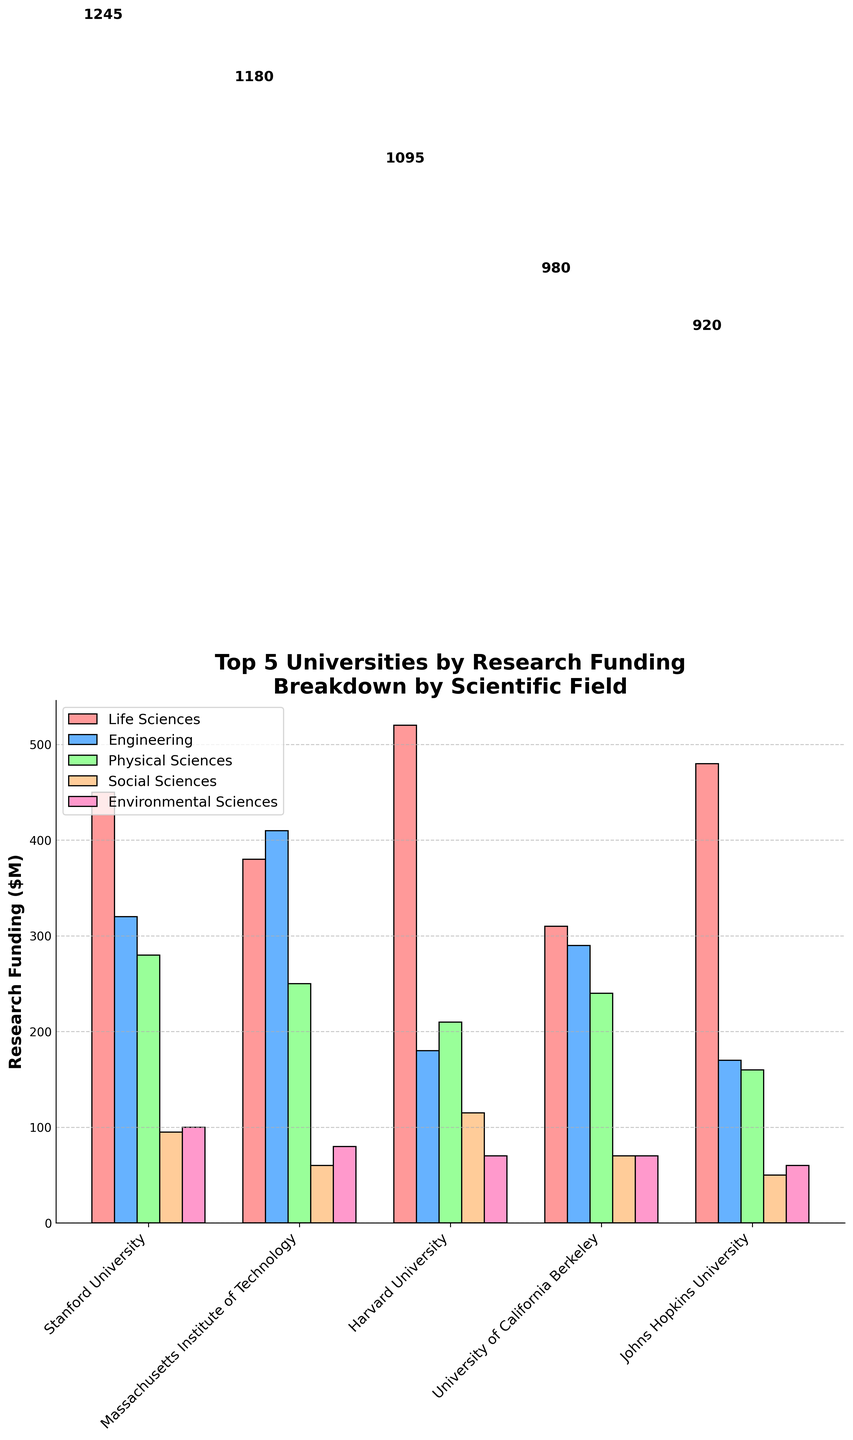What university has the highest total research funding? Scan the chart to find the university with the tallest bar representing total research funding. Stanford University has the tallest bar with 1245 million dollars.
Answer: Stanford University Which scientific field receives the most funding at Massachusetts Institute of Technology (MIT)? Observe the different colored bars representing scientific fields at MIT. The blue bar (Engineering) is the tallest, indicating Engineering receives the most funding.
Answer: Engineering What is the total funding for Life Sciences across all universities shown? Sum the Life Sciences funding for each university: 450 (Stanford) + 380 (MIT) + 520 (Harvard) + 310 (UC Berkeley) + 480 (Johns Hopkins) = 2140.
Answer: 2140 How does the funding for Physical Sciences at Harvard University compare to that at Stanford University? Compare the heights of the green bars (Physical Sciences) for Harvard (210) and Stanford (280). Stanford University receives more funding for Physical Sciences.
Answer: Stanford University has more What is the sum of the funding for Social Sciences and Environmental Sciences at Johns Hopkins University? Sum the Social Sciences funding (50) and Environmental Sciences funding (60) for Johns Hopkins University: 50 + 60 = 110.
Answer: 110 Which university has the lowest funding in Social Sciences? Observe the yellow bars (Social Sciences) for all universities. MIT has the smallest yellow bar with 60 million dollars in funding.
Answer: MIT Is the Environmental Sciences funding greater at Stanford University or UC Berkeley? Compare the height of the pink bars (Environmental Sciences) at Stanford University (100) and UC Berkeley (70). Stanford University has greater funding.
Answer: Stanford University What is the average research funding per university for Physical Sciences? Sum the Physical Sciences funding for each university and divide by the number of universities: (280 + 250 + 210 + 240 + 160) / 5 = 1140 / 5 = 228.
Answer: 228 Which university has a more balanced distribution of funding across the scientific fields? Look for a university where the bars for different scientific fields have similar heights. UC Berkeley has relatively similar heights among its bars for different fields.
Answer: UC Berkeley How does the total research funding of Harvard University compare to that of UC Berkeley and MIT combined? Sum the total funding for UC Berkeley (980) and MIT (1180) to compare with Harvard (1095): 980 + 1180 = 2160. Harvard’s funding is less than the sum of UC Berkeley and MIT.
Answer: Less than the sum of UC Berkeley and MIT's funding 